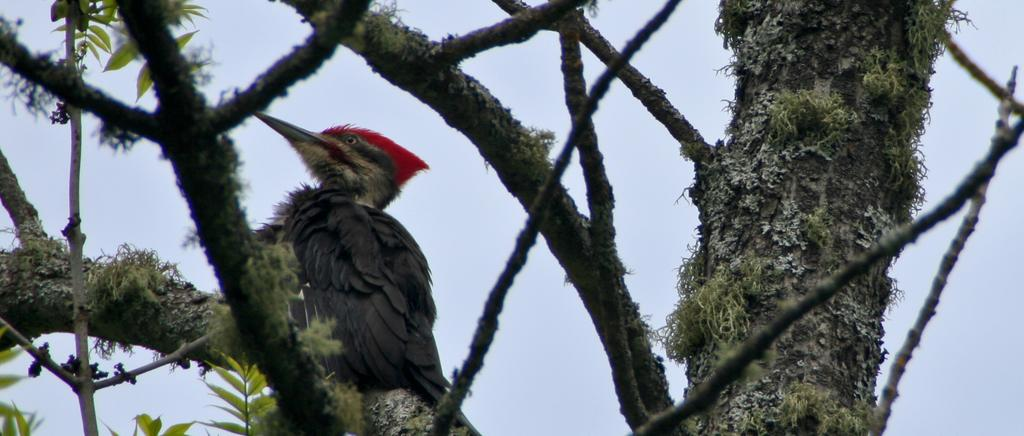What type of vegetation can be seen in the image? There are branches and leaves in the image. Is there any wildlife present in the image? Yes, there is a bird on a branch in the image. What can be seen in the background of the image? The sky is visible in the background of the image. What type of disgust can be seen on the bird's face in the image? There is no indication of any emotion, such as disgust, on the bird's face in the image. Are there any harbors or waves visible in the image? No, there are no harbors or waves present in the image; it features a bird on a branch with branches and leaves. 